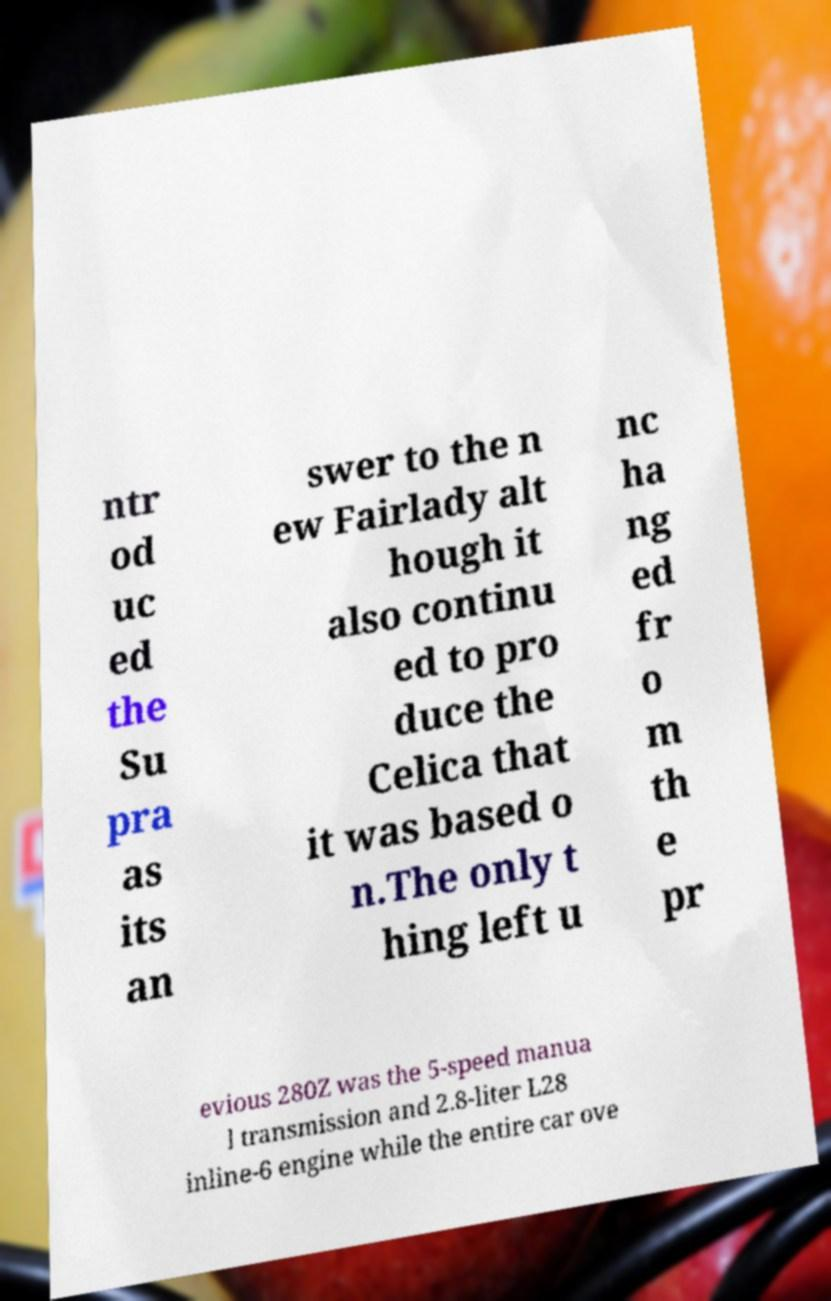Can you read and provide the text displayed in the image?This photo seems to have some interesting text. Can you extract and type it out for me? ntr od uc ed the Su pra as its an swer to the n ew Fairlady alt hough it also continu ed to pro duce the Celica that it was based o n.The only t hing left u nc ha ng ed fr o m th e pr evious 280Z was the 5-speed manua l transmission and 2.8-liter L28 inline-6 engine while the entire car ove 